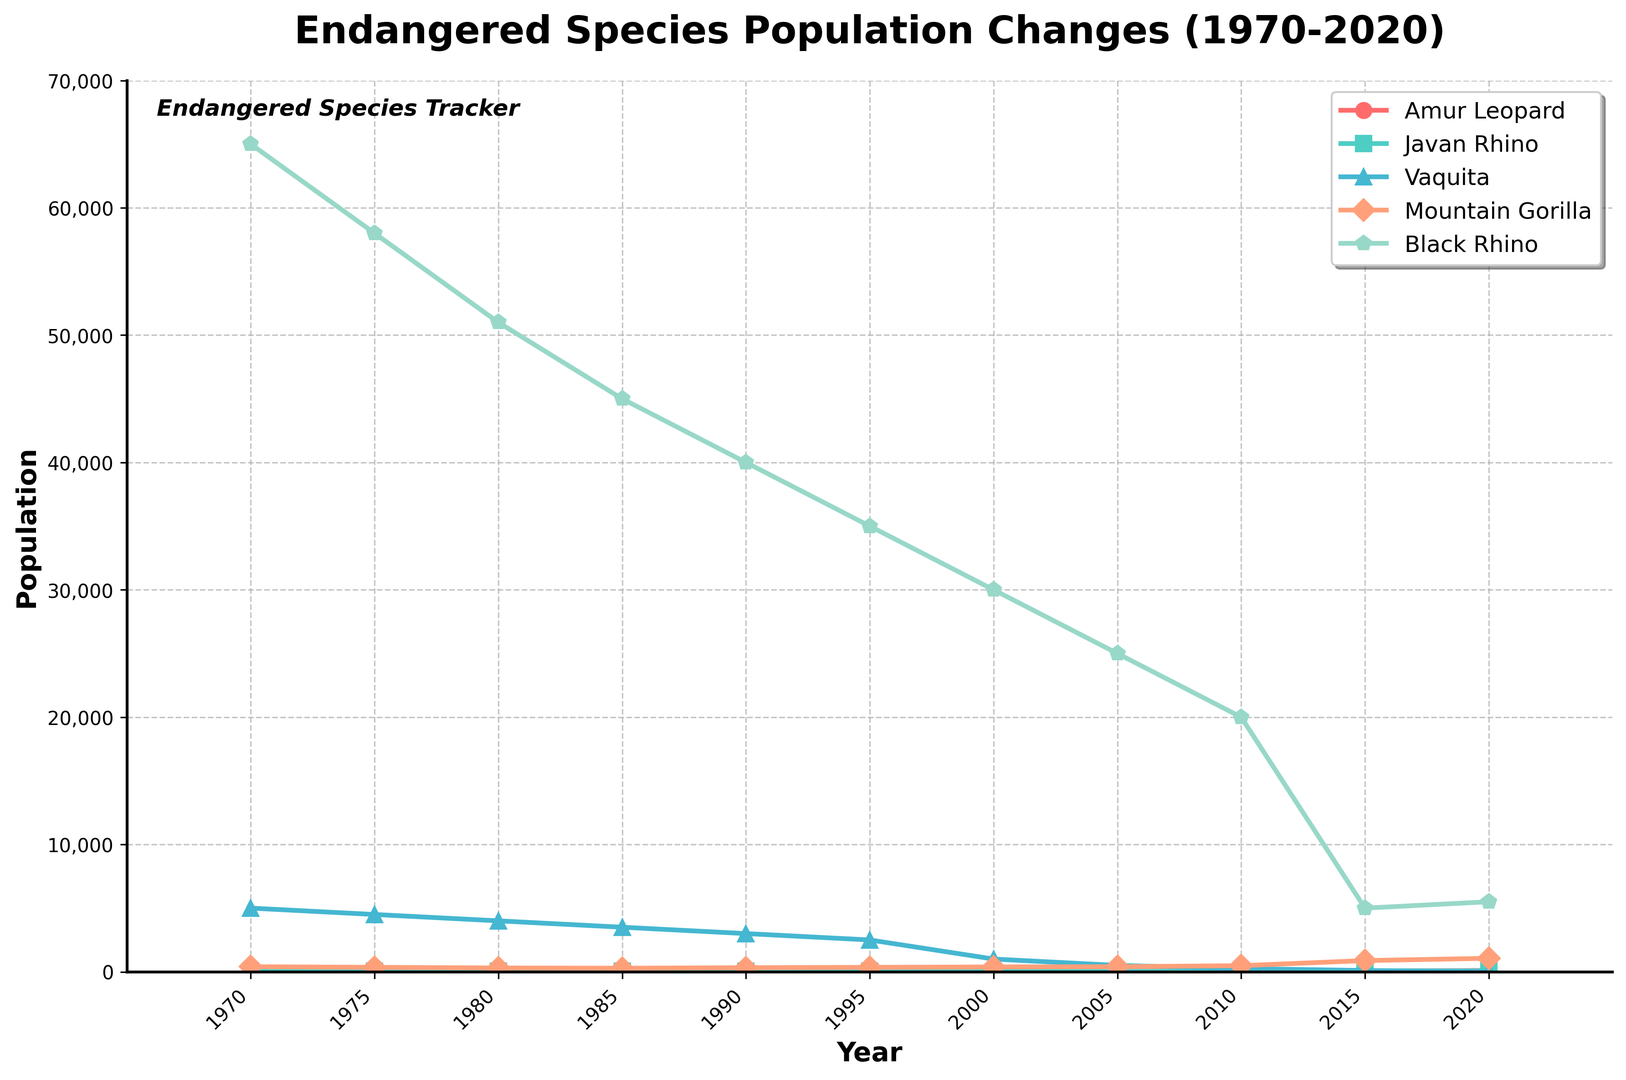Which animal had the highest population in 1970? To find this, look at the population values for all animals in 1970 and identify the highest one. The Black Rhino had a population of 65,000, which is the highest.
Answer: Black Rhino Did the Mountain Gorilla population increase or decrease between 1985 and 2020? Compare the values for the years 1985 (280) and 2020 (1,060). The population increased.
Answer: Increased Which animal had the most significant population drop between 1990 and 2000? Calculate the differences for all animals between 1990 and 2000: Amur Leopard (60 to 40), Javan Rhino (45 to 35), Vaquita (3,000 to 1,000), Mountain Gorilla (320 to 380), Black Rhino (40,000 to 30,000). The Vaquita dropped by 2,000.
Answer: Vaquita By what percentage did the Javan Rhino population change from 2005 to 2015? The population in 2005 was 30 and in 2015 it was 65. The percentage change is ((65-30)/30) * 100 = 116.7%.
Answer: 116.7% Which year did the Amur Leopard population start showing signs of recovery? Examine the population values for the Amur Leopard over the years. The population starts to increase again in 2015 (60).
Answer: 2015 How does the population trend of the Vaquita compare to the Black Rhino from 1970 to 2020? Look at both population lines from 1970 to 2020. The Vaquita shows a consistent decline, hitting almost zero in 2020. The Black Rhino shows a substantial decline but has increased slightly in the last few years.
Answer: Vaquita consistently declined; Black Rhino initially declined, then slightly increased What was the total combined population of all five species in 1990? Sum the populations of all five species in 1990: Amur Leopard (60), Javan Rhino (45), Vaquita (3,000), Mountain Gorilla (320), Black Rhino (40,000). The total is 43,425.
Answer: 43,425 Which animal had the most stable population trend over the 50 years? Look at the lines' stability in the plot. The Javan Rhino shows relatively stable changes compared to the sharp fluctuations in the population of the other animals.
Answer: Javan Rhino In which year did the Mountain Gorilla population surpass that of the Black Rhino? Compare the population values for both species year by year. In 2020, the Mountain Gorilla (1,060) surpasses the Black Rhino (5,500).
Answer: Never What are the populations of Amur Leopard, Javan Rhino, and Vaquita in the year 2015, and what is their sum? Read the values directly from the graph for the year 2015: Amur Leopard (60), Javan Rhino (65), Vaquita (100). Their sum is 60 + 65 + 100 = 225.
Answer: 225 